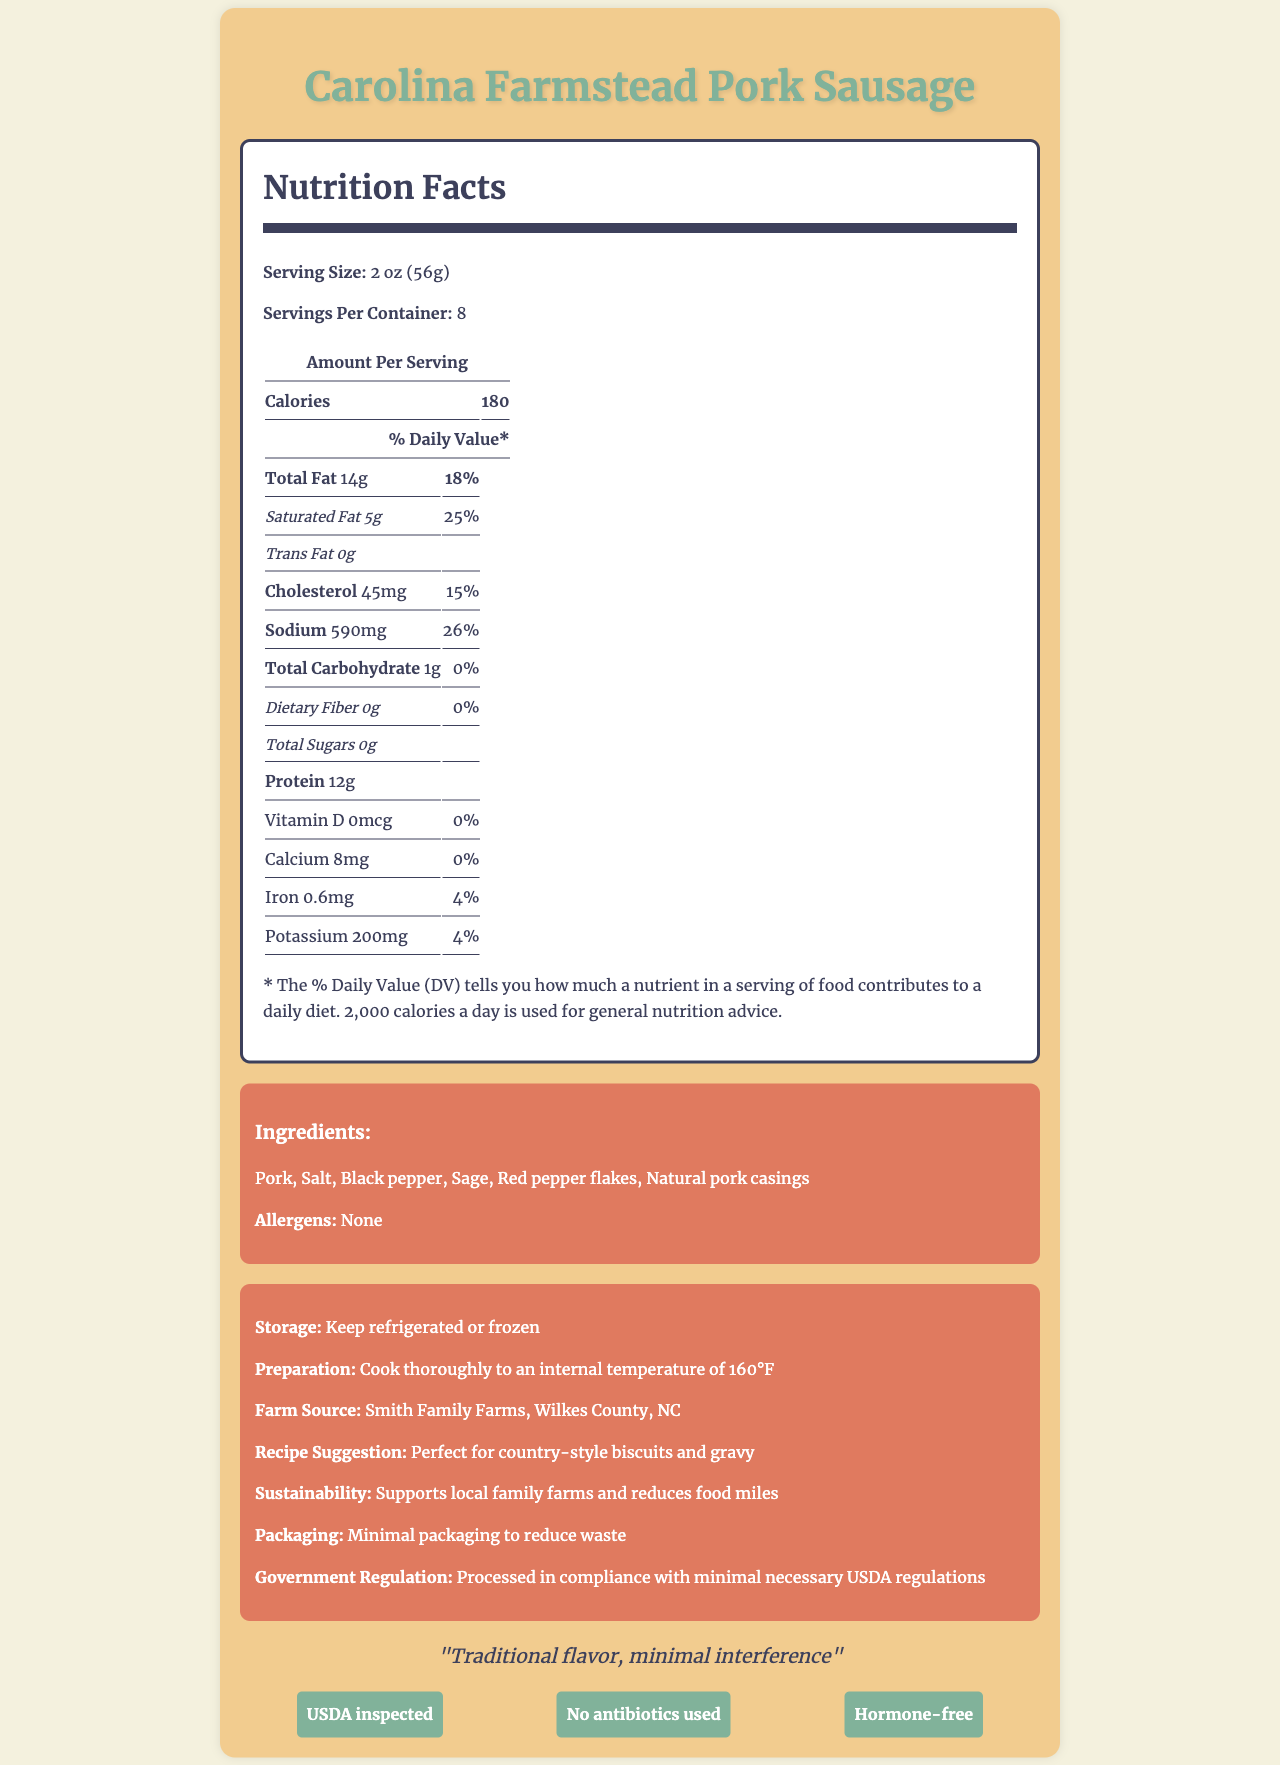what is the serving size of the Carolina Farmstead Pork Sausage? The serving size information is listed next to the product name under "Serving Size: 2 oz (56g)".
Answer: 2 oz (56g) how many servings are there per container? The number of servings per container is listed as "Servings Per Container: 8".
Answer: 8 what is the total fat content per serving? The total fat content per serving is listed as "Total Fat 14g".
Answer: 14g what percentage of the daily value is the sodium content per serving? The daily value percentage for sodium content per serving is listed as "Sodium 590mg, 26%".
Answer: 26% what are the preparation instructions for the sausage? The preparation instructions are listed under "Preparation: Cook thoroughly to an internal temperature of 160°F".
Answer: Cook thoroughly to an internal temperature of 160°F what is the main protein source in the ingredients? The main protein source is listed as the first ingredient in the list: "Pork".
Answer: Pork which farm source provides the pork for the sausage? A. Johnson Family Farm, Wilkes County, NC B. Smith Family Farms, Wilkes County, NC C. Green Meadow Farm, Wilkes County, NC The farm source listed is "Smith Family Farms, Wilkes County, NC".
Answer: B what is one of the certifications for the product? A. Organic B. USDA inspected C. Non-GMO One of the certifications listed is "USDA inspected".
Answer: B is this sausage product made with antibiotics? The document lists a certification "No antibiotics used", indicating that the sausage is made without antibiotics.
Answer: No how many calories are there per serving? The number of calories per serving is listed as "Calories 180".
Answer: 180 what is the slogan for the Carolina Farmstead Pork Sausage? The slogan is listed at the bottom of the document: "Traditional flavor, minimal interference".
Answer: Traditional flavor, minimal interference which vitamin or mineral is most prevalent in the sausage based on daily value percentage? Sodium has the highest daily value percentage at 26%.
Answer: Sodium how many grams of protein are there per serving? The protein content per serving is listed as "Protein 12g".
Answer: 12g what is the sustainability claim made for this product? The sustainability claim is stated under "Sustainability: Supports local family farms and reduces food miles".
Answer: Supports local family farms and reduces food miles describe the main purpose and content of this document. This document details the nutritional facts, ingredient list, certifications, and various claims related to the product's sourcing, sustainability, and packaging. It also includes preparation and storage instructions, emphasizing its minimal government regulation and support for local family farms.
Answer: The document provides nutritional information, ingredients, preparation instructions, and certifications for Carolina Farmstead Pork Sausage. It also includes details about the farm source, storage instructions, and sustainability practices. what is the vitamin D content per serving? The vitamin D content per serving is listed as "Vitamin D 0mcg".
Answer: 0mcg what government regulation comment is made in the document? The government regulation detail is listed under "Government Regulation: Processed in compliance with minimal necessary USDA regulations".
Answer: Processed in compliance with minimal necessary USDA regulations where does the product claim to reduce waste? The product claims to reduce waste with its packaging: "Packaging: Minimal packaging to reduce waste".
Answer: Packaging how much iron does one serving contribute to the daily value? The daily value percentage for iron per serving is listed as "Iron 0.6mg, 4%".
Answer: 4% does the document provide details on product allergens? The allergens section states: "Allergens: None".
Answer: Yes what is the total carbohydrate content per serving? The total carbohydrate content per serving is listed as "Total Carbohydrate 1g".
Answer: 1g is there any fiber in the sausage? The dietary fiber content is listed as "Dietary Fiber 0g".
Answer: No who manufactures the sausage? The document does not specify the manufacturer of the sausage.
Answer: Not enough information 